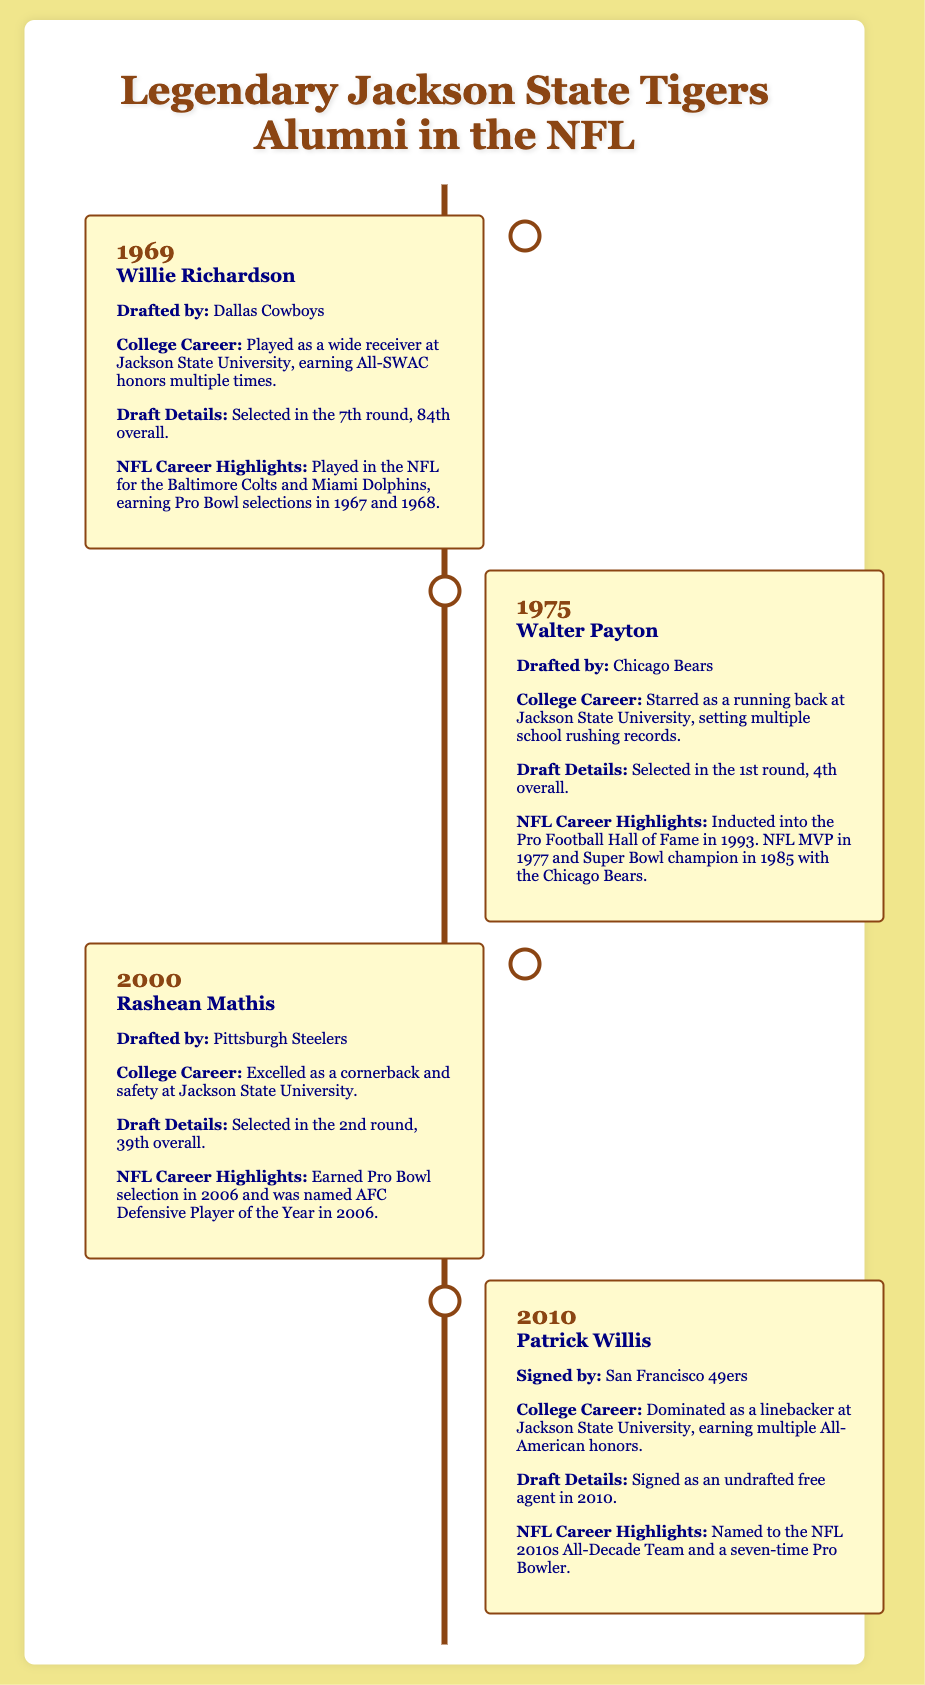What year was Willie Richardson drafted? Willie Richardson was drafted in 1969, as stated in the timeline.
Answer: 1969 Which team drafted Walter Payton? Walter Payton was drafted by the Chicago Bears, which is clearly indicated in the document.
Answer: Chicago Bears What round was Rashean Mathis drafted in? Rashean Mathis was drafted in the 2nd round, as specified in the timeline.
Answer: 2nd round How many Pro Bowl selections did Patrick Willis earn? Patrick Willis earned seven Pro Bowl selections during his NFL career, as mentioned in the document.
Answer: seven What position did Willie Richardson play? Willie Richardson played as a wide receiver at Jackson State University, as per the timeline.
Answer: wide receiver Which NFL legend was inducted into the Pro Football Hall of Fame in 1993? Walter Payton was the NFL legend inducted into the Pro Football Hall of Fame in 1993, according to the timeline.
Answer: Walter Payton In what year did Rashean Mathis earn the title of AFC Defensive Player of the Year? Rashean Mathis earned the title of AFC Defensive Player of the Year in 2006, as described in the document.
Answer: 2006 How many times did Patrick Willis earn All-American honors in college? Patrick Willis earned multiple All-American honors during his college career, as stated in the timeline.
Answer: multiple What position did Patrick Willis play at Jackson State University? Patrick Willis played as a linebacker at Jackson State University, as indicated in the document.
Answer: linebacker 